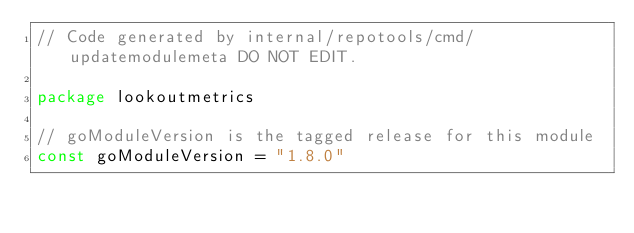<code> <loc_0><loc_0><loc_500><loc_500><_Go_>// Code generated by internal/repotools/cmd/updatemodulemeta DO NOT EDIT.

package lookoutmetrics

// goModuleVersion is the tagged release for this module
const goModuleVersion = "1.8.0"
</code> 